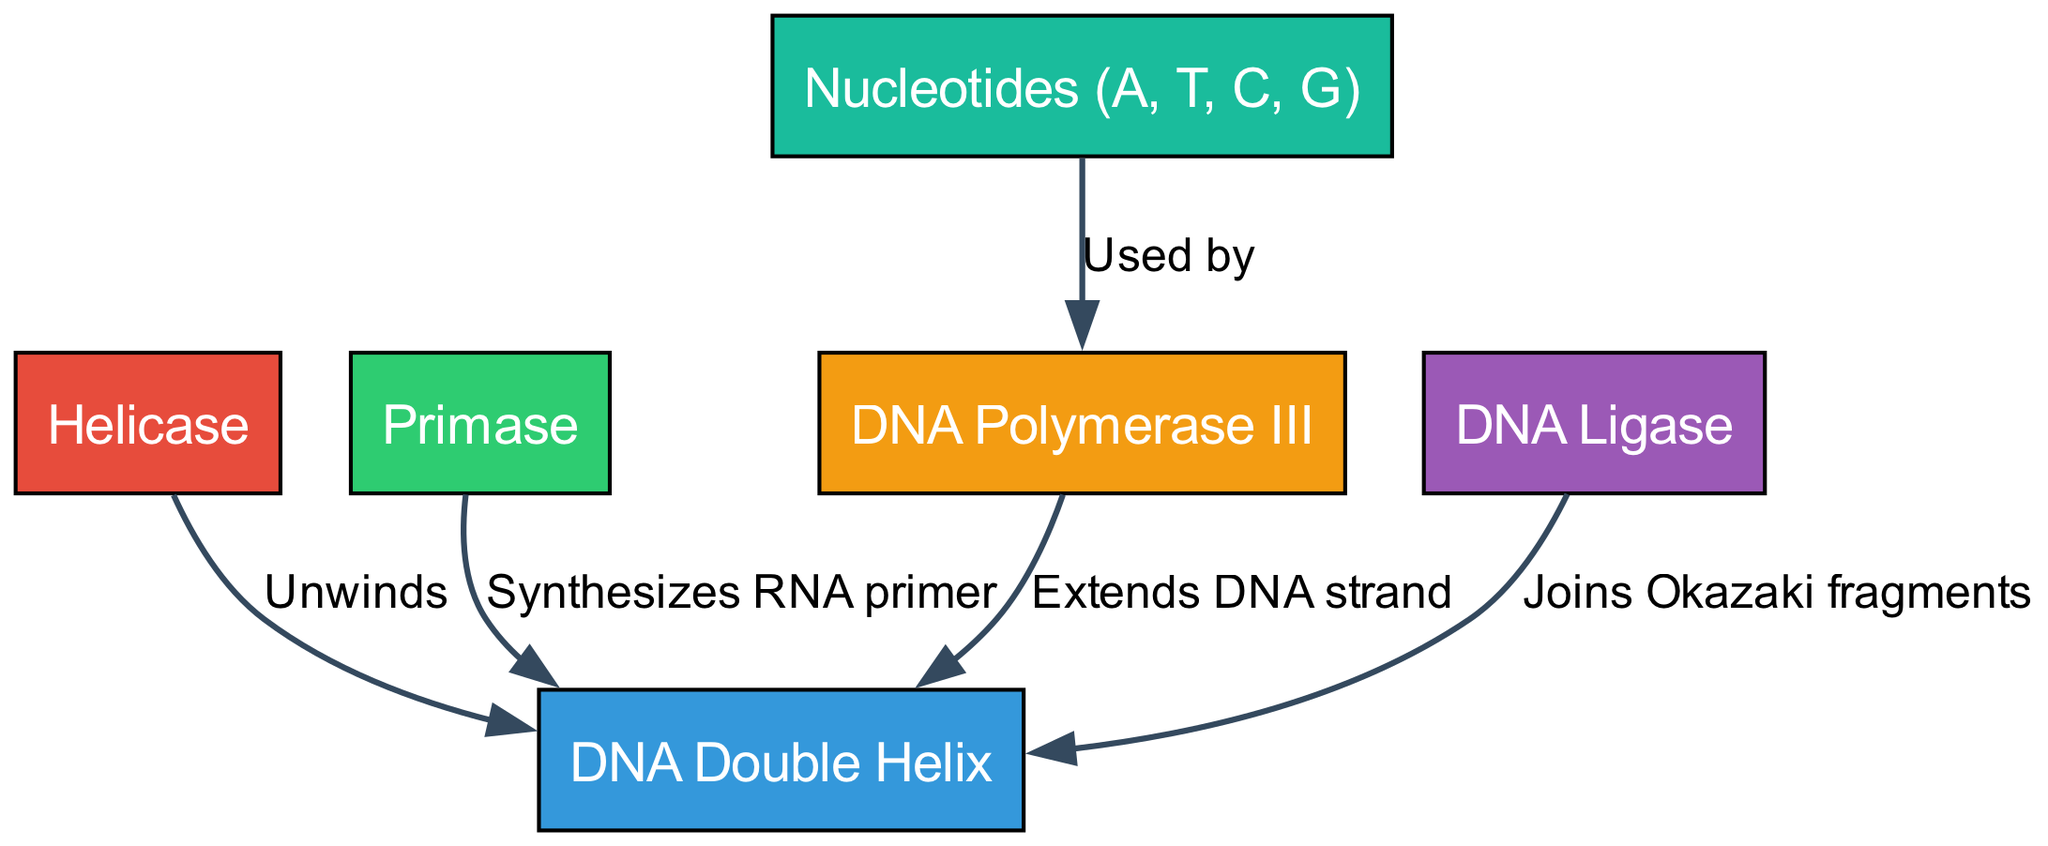What is the first enzyme involved in DNA replication? The diagram shows that the first enzyme connected to the DNA Double Helix is Helicase, indicated by the edge labeled "Unwinds."
Answer: Helicase What does Primase do in the DNA replication process? The diagram illustrates that Primase synthesizes an RNA primer, as indicated by the edge that connects Primase to the DNA Double Helix with the label "Synthesizes RNA primer."
Answer: Synthesizes RNA primer How many nucleotides are mentioned in the diagram? The diagram includes a single node labeled "Nucleotides (A, T, C, G)", so there is one node representing nucleotides.
Answer: One What does DNA Ligase do during DNA replication? The diagram specifies that DNA Ligase joins Okazaki fragments, as indicated by the arrow leading from Ligase to the DNA, labeled "Joins Okazaki fragments."
Answer: Joins Okazaki fragments Which enzyme is responsible for extending the DNA strand? Examining the diagram, it shows that DNA Polymerase III extends the DNA strand, as connected by the edge labeled "Extends DNA strand."
Answer: DNA Polymerase III How are nucleotides utilized in the DNA replication process? The diagram indicates that nucleotides are used by DNA Polymerase III, connected by the edge labeled "Used by." This shows that they serve as building blocks for extending the DNA strand.
Answer: Used by DNA Polymerase III What is the relationship between Helicase and the DNA Double Helix? The relationship is established through the edge labeled "Unwinds," which indicates the action performed by Helicase on the DNA Double Helix.
Answer: Unwinds Which enzyme synthesizes the RNA primer? Looking at the diagram, it clearly shows that Primase is the enzyme that synthesizes the RNA primer, as indicated by the edge "Synthesizes RNA primer" connecting it to the DNA Double Helix.
Answer: Primase How are Okazaki fragments joined during DNA replication? The diagram indicates that the enzyme responsible for joining Okazaki fragments is DNA Ligase, with the edge labeled "Joins Okazaki fragments" leading to the DNA Double Helix.
Answer: DNA Ligase 